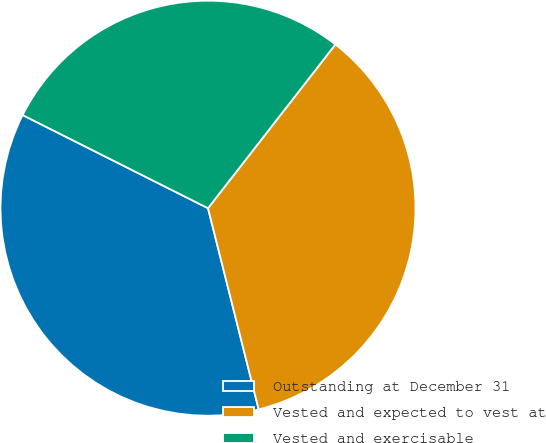<chart> <loc_0><loc_0><loc_500><loc_500><pie_chart><fcel>Outstanding at December 31<fcel>Vested and expected to vest at<fcel>Vested and exercisable<nl><fcel>36.34%<fcel>35.55%<fcel>28.11%<nl></chart> 